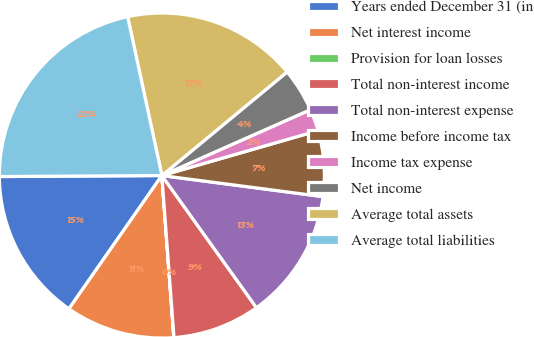Convert chart to OTSL. <chart><loc_0><loc_0><loc_500><loc_500><pie_chart><fcel>Years ended December 31 (in<fcel>Net interest income<fcel>Provision for loan losses<fcel>Total non-interest income<fcel>Total non-interest expense<fcel>Income before income tax<fcel>Income tax expense<fcel>Net income<fcel>Average total assets<fcel>Average total liabilities<nl><fcel>15.21%<fcel>10.87%<fcel>0.01%<fcel>8.7%<fcel>13.04%<fcel>6.53%<fcel>2.18%<fcel>4.36%<fcel>17.38%<fcel>21.72%<nl></chart> 